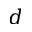<formula> <loc_0><loc_0><loc_500><loc_500>d</formula> 